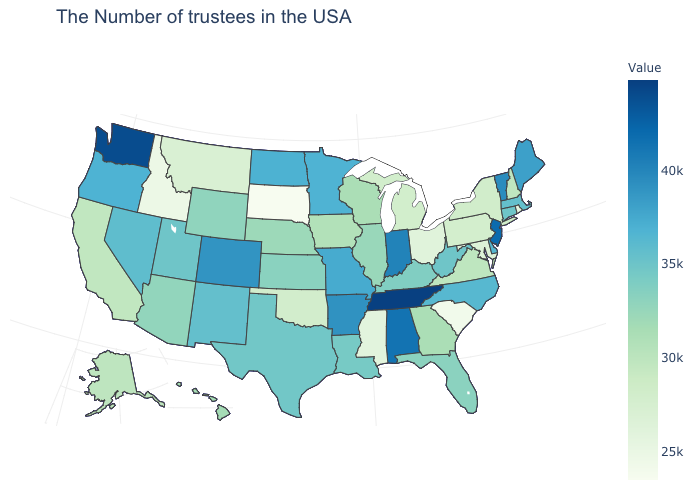Does the map have missing data?
Concise answer only. No. Among the states that border Indiana , which have the lowest value?
Be succinct. Ohio. Among the states that border Nevada , does Idaho have the lowest value?
Be succinct. Yes. Is the legend a continuous bar?
Keep it brief. Yes. 